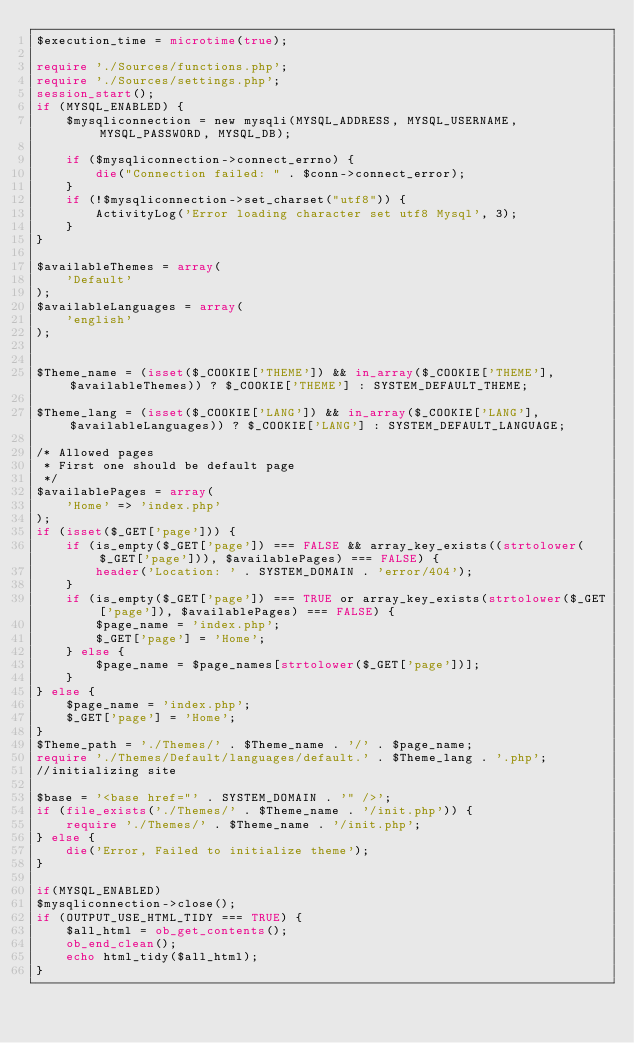<code> <loc_0><loc_0><loc_500><loc_500><_PHP_>$execution_time = microtime(true);

require './Sources/functions.php';
require './Sources/settings.php';
session_start();
if (MYSQL_ENABLED) {
    $mysqliconnection = new mysqli(MYSQL_ADDRESS, MYSQL_USERNAME, MYSQL_PASSWORD, MYSQL_DB);

    if ($mysqliconnection->connect_errno) {
        die("Connection failed: " . $conn->connect_error);
    }
    if (!$mysqliconnection->set_charset("utf8")) {
        ActivityLog('Error loading character set utf8 Mysql', 3);
    }
}

$availableThemes = array(
    'Default'
);
$availableLanguages = array(
    'english'
);


$Theme_name = (isset($_COOKIE['THEME']) && in_array($_COOKIE['THEME'], $availableThemes)) ? $_COOKIE['THEME'] : SYSTEM_DEFAULT_THEME;

$Theme_lang = (isset($_COOKIE['LANG']) && in_array($_COOKIE['LANG'], $availableLanguages)) ? $_COOKIE['LANG'] : SYSTEM_DEFAULT_LANGUAGE;

/* Allowed pages
 * First one should be default page
 */
$availablePages = array(
    'Home' => 'index.php'
);
if (isset($_GET['page'])) {
    if (is_empty($_GET['page']) === FALSE && array_key_exists((strtolower($_GET['page'])), $availablePages) === FALSE) {
        header('Location: ' . SYSTEM_DOMAIN . 'error/404');
    }
    if (is_empty($_GET['page']) === TRUE or array_key_exists(strtolower($_GET['page']), $availablePages) === FALSE) {
        $page_name = 'index.php';
        $_GET['page'] = 'Home';
    } else {
        $page_name = $page_names[strtolower($_GET['page'])];
    }
} else {
    $page_name = 'index.php';
    $_GET['page'] = 'Home';
}
$Theme_path = './Themes/' . $Theme_name . '/' . $page_name;
require './Themes/Default/languages/default.' . $Theme_lang . '.php';
//initializing site

$base = '<base href="' . SYSTEM_DOMAIN . '" />';
if (file_exists('./Themes/' . $Theme_name . '/init.php')) {
    require './Themes/' . $Theme_name . '/init.php';
} else {
    die('Error, Failed to initialize theme');
}

if(MYSQL_ENABLED)
$mysqliconnection->close();
if (OUTPUT_USE_HTML_TIDY === TRUE) {
    $all_html = ob_get_contents();
    ob_end_clean();
    echo html_tidy($all_html);
}</code> 